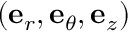<formula> <loc_0><loc_0><loc_500><loc_500>( { e } _ { r } , { e } _ { \theta } , { e } _ { z } )</formula> 